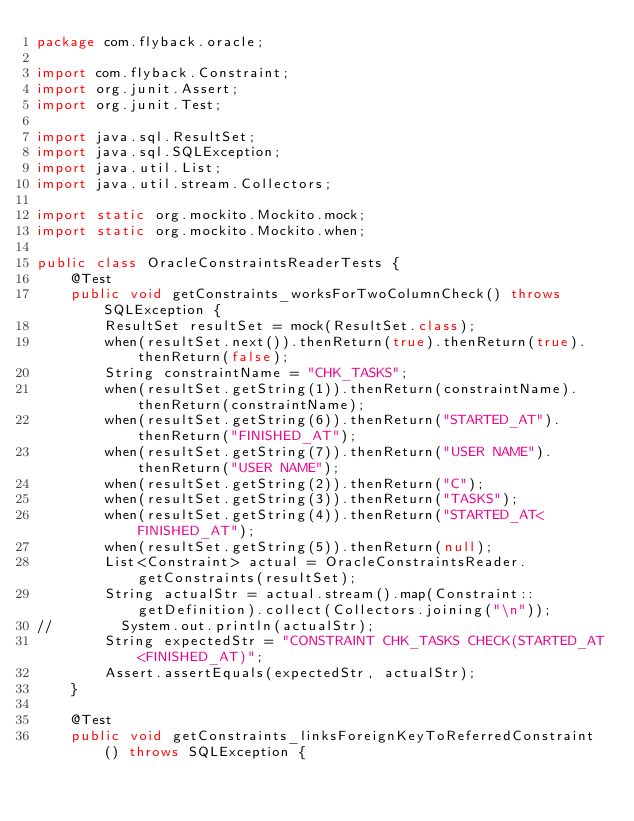Convert code to text. <code><loc_0><loc_0><loc_500><loc_500><_Java_>package com.flyback.oracle;

import com.flyback.Constraint;
import org.junit.Assert;
import org.junit.Test;

import java.sql.ResultSet;
import java.sql.SQLException;
import java.util.List;
import java.util.stream.Collectors;

import static org.mockito.Mockito.mock;
import static org.mockito.Mockito.when;

public class OracleConstraintsReaderTests {
    @Test
    public void getConstraints_worksForTwoColumnCheck() throws SQLException {
        ResultSet resultSet = mock(ResultSet.class);
        when(resultSet.next()).thenReturn(true).thenReturn(true).thenReturn(false);
        String constraintName = "CHK_TASKS";
        when(resultSet.getString(1)).thenReturn(constraintName).thenReturn(constraintName);
        when(resultSet.getString(6)).thenReturn("STARTED_AT").thenReturn("FINISHED_AT");
        when(resultSet.getString(7)).thenReturn("USER NAME").thenReturn("USER NAME");
        when(resultSet.getString(2)).thenReturn("C");
        when(resultSet.getString(3)).thenReturn("TASKS");
        when(resultSet.getString(4)).thenReturn("STARTED_AT<FINISHED_AT");
        when(resultSet.getString(5)).thenReturn(null);
        List<Constraint> actual = OracleConstraintsReader.getConstraints(resultSet);
        String actualStr = actual.stream().map(Constraint::getDefinition).collect(Collectors.joining("\n"));
//        System.out.println(actualStr);
        String expectedStr = "CONSTRAINT CHK_TASKS CHECK(STARTED_AT<FINISHED_AT)";
        Assert.assertEquals(expectedStr, actualStr);
    }

    @Test
    public void getConstraints_linksForeignKeyToReferredConstraint() throws SQLException {</code> 